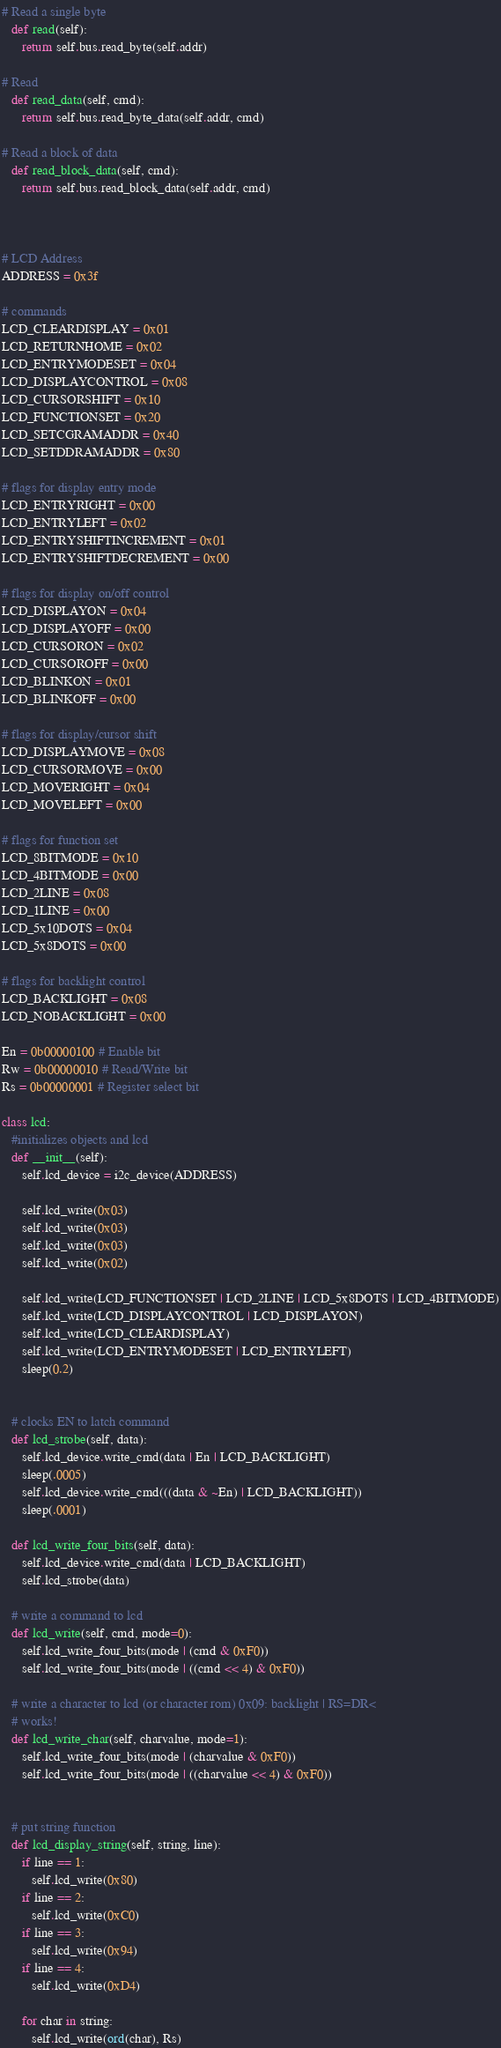Convert code to text. <code><loc_0><loc_0><loc_500><loc_500><_Python_>
# Read a single byte
   def read(self):
      return self.bus.read_byte(self.addr)

# Read
   def read_data(self, cmd):
      return self.bus.read_byte_data(self.addr, cmd)

# Read a block of data
   def read_block_data(self, cmd):
      return self.bus.read_block_data(self.addr, cmd)



# LCD Address
ADDRESS = 0x3f

# commands
LCD_CLEARDISPLAY = 0x01
LCD_RETURNHOME = 0x02
LCD_ENTRYMODESET = 0x04
LCD_DISPLAYCONTROL = 0x08
LCD_CURSORSHIFT = 0x10
LCD_FUNCTIONSET = 0x20
LCD_SETCGRAMADDR = 0x40
LCD_SETDDRAMADDR = 0x80

# flags for display entry mode
LCD_ENTRYRIGHT = 0x00
LCD_ENTRYLEFT = 0x02
LCD_ENTRYSHIFTINCREMENT = 0x01
LCD_ENTRYSHIFTDECREMENT = 0x00

# flags for display on/off control
LCD_DISPLAYON = 0x04
LCD_DISPLAYOFF = 0x00
LCD_CURSORON = 0x02
LCD_CURSOROFF = 0x00
LCD_BLINKON = 0x01
LCD_BLINKOFF = 0x00

# flags for display/cursor shift
LCD_DISPLAYMOVE = 0x08
LCD_CURSORMOVE = 0x00
LCD_MOVERIGHT = 0x04
LCD_MOVELEFT = 0x00

# flags for function set
LCD_8BITMODE = 0x10
LCD_4BITMODE = 0x00
LCD_2LINE = 0x08
LCD_1LINE = 0x00
LCD_5x10DOTS = 0x04
LCD_5x8DOTS = 0x00

# flags for backlight control
LCD_BACKLIGHT = 0x08
LCD_NOBACKLIGHT = 0x00

En = 0b00000100 # Enable bit
Rw = 0b00000010 # Read/Write bit
Rs = 0b00000001 # Register select bit

class lcd:
   #initializes objects and lcd
   def __init__(self):
      self.lcd_device = i2c_device(ADDRESS)

      self.lcd_write(0x03)
      self.lcd_write(0x03)
      self.lcd_write(0x03)
      self.lcd_write(0x02)

      self.lcd_write(LCD_FUNCTIONSET | LCD_2LINE | LCD_5x8DOTS | LCD_4BITMODE)
      self.lcd_write(LCD_DISPLAYCONTROL | LCD_DISPLAYON)
      self.lcd_write(LCD_CLEARDISPLAY)
      self.lcd_write(LCD_ENTRYMODESET | LCD_ENTRYLEFT)
      sleep(0.2)


   # clocks EN to latch command
   def lcd_strobe(self, data):
      self.lcd_device.write_cmd(data | En | LCD_BACKLIGHT)
      sleep(.0005)
      self.lcd_device.write_cmd(((data & ~En) | LCD_BACKLIGHT))
      sleep(.0001)

   def lcd_write_four_bits(self, data):
      self.lcd_device.write_cmd(data | LCD_BACKLIGHT)
      self.lcd_strobe(data)

   # write a command to lcd
   def lcd_write(self, cmd, mode=0):
      self.lcd_write_four_bits(mode | (cmd & 0xF0))
      self.lcd_write_four_bits(mode | ((cmd << 4) & 0xF0))

   # write a character to lcd (or character rom) 0x09: backlight | RS=DR<
   # works!
   def lcd_write_char(self, charvalue, mode=1):
      self.lcd_write_four_bits(mode | (charvalue & 0xF0))
      self.lcd_write_four_bits(mode | ((charvalue << 4) & 0xF0))


   # put string function
   def lcd_display_string(self, string, line):
      if line == 1:
         self.lcd_write(0x80)
      if line == 2:
         self.lcd_write(0xC0)
      if line == 3:
         self.lcd_write(0x94)
      if line == 4:
         self.lcd_write(0xD4)

      for char in string:
         self.lcd_write(ord(char), Rs)
</code> 